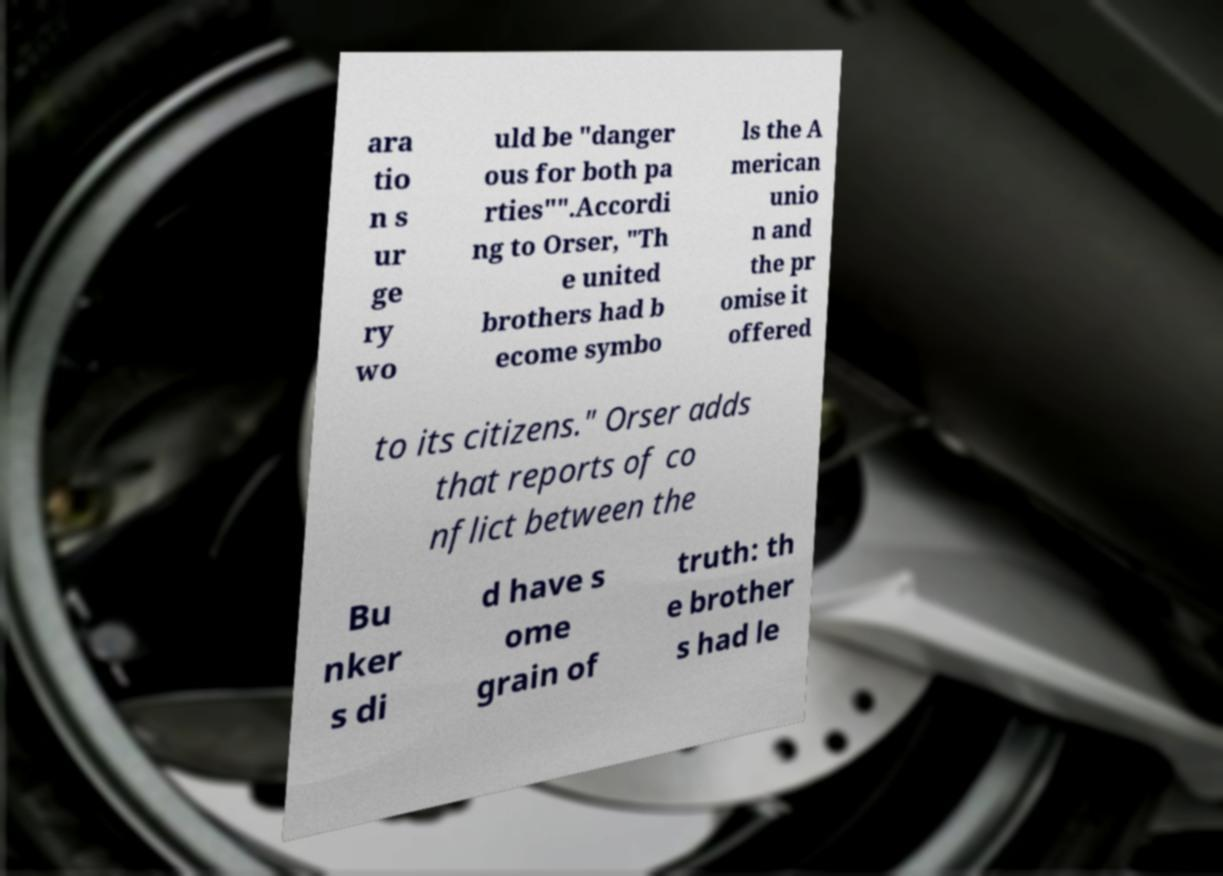There's text embedded in this image that I need extracted. Can you transcribe it verbatim? ara tio n s ur ge ry wo uld be "danger ous for both pa rties"".Accordi ng to Orser, "Th e united brothers had b ecome symbo ls the A merican unio n and the pr omise it offered to its citizens." Orser adds that reports of co nflict between the Bu nker s di d have s ome grain of truth: th e brother s had le 